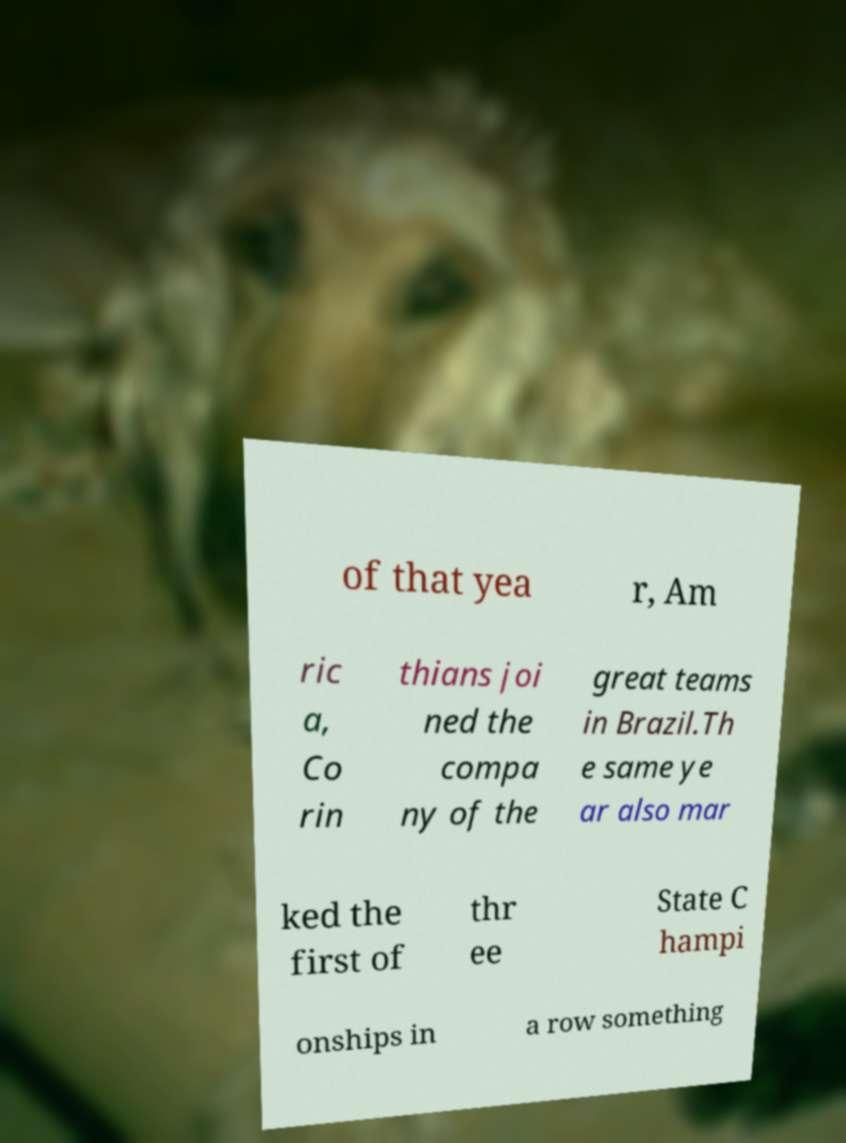What messages or text are displayed in this image? I need them in a readable, typed format. of that yea r, Am ric a, Co rin thians joi ned the compa ny of the great teams in Brazil.Th e same ye ar also mar ked the first of thr ee State C hampi onships in a row something 